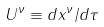Convert formula to latex. <formula><loc_0><loc_0><loc_500><loc_500>U ^ { \nu } \equiv d x ^ { \nu } / d \tau</formula> 